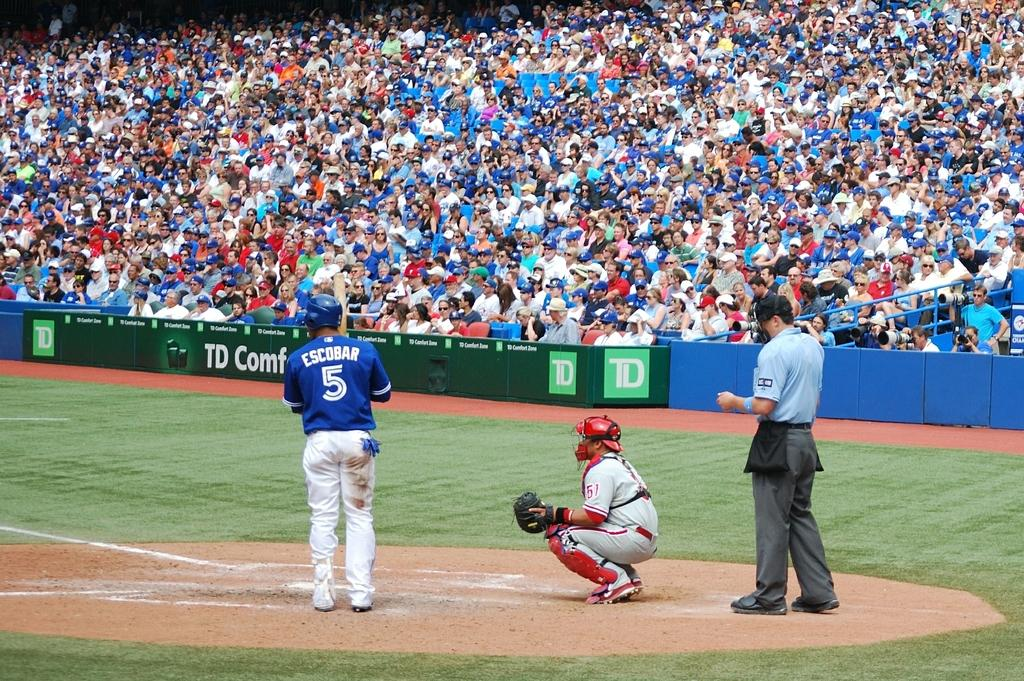<image>
Write a terse but informative summary of the picture. Escobar, who is number 5, is up to bat. 